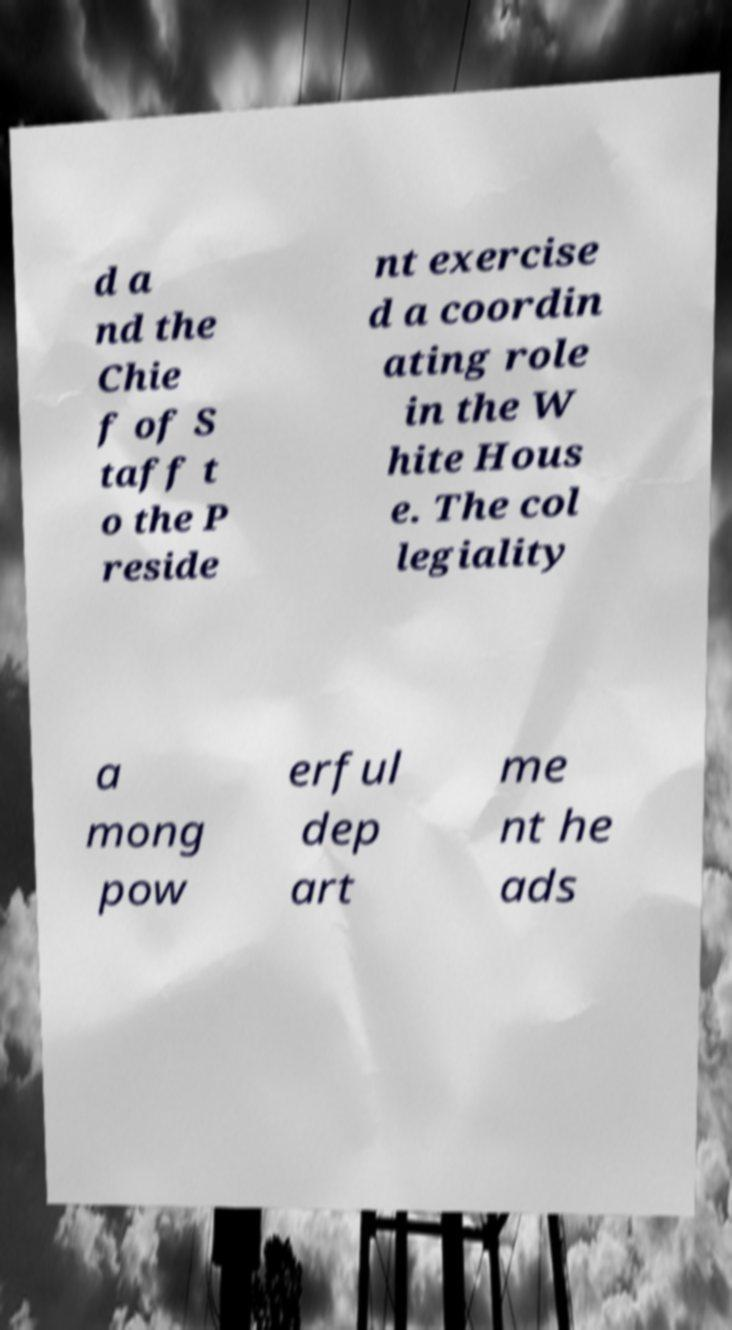There's text embedded in this image that I need extracted. Can you transcribe it verbatim? d a nd the Chie f of S taff t o the P reside nt exercise d a coordin ating role in the W hite Hous e. The col legiality a mong pow erful dep art me nt he ads 